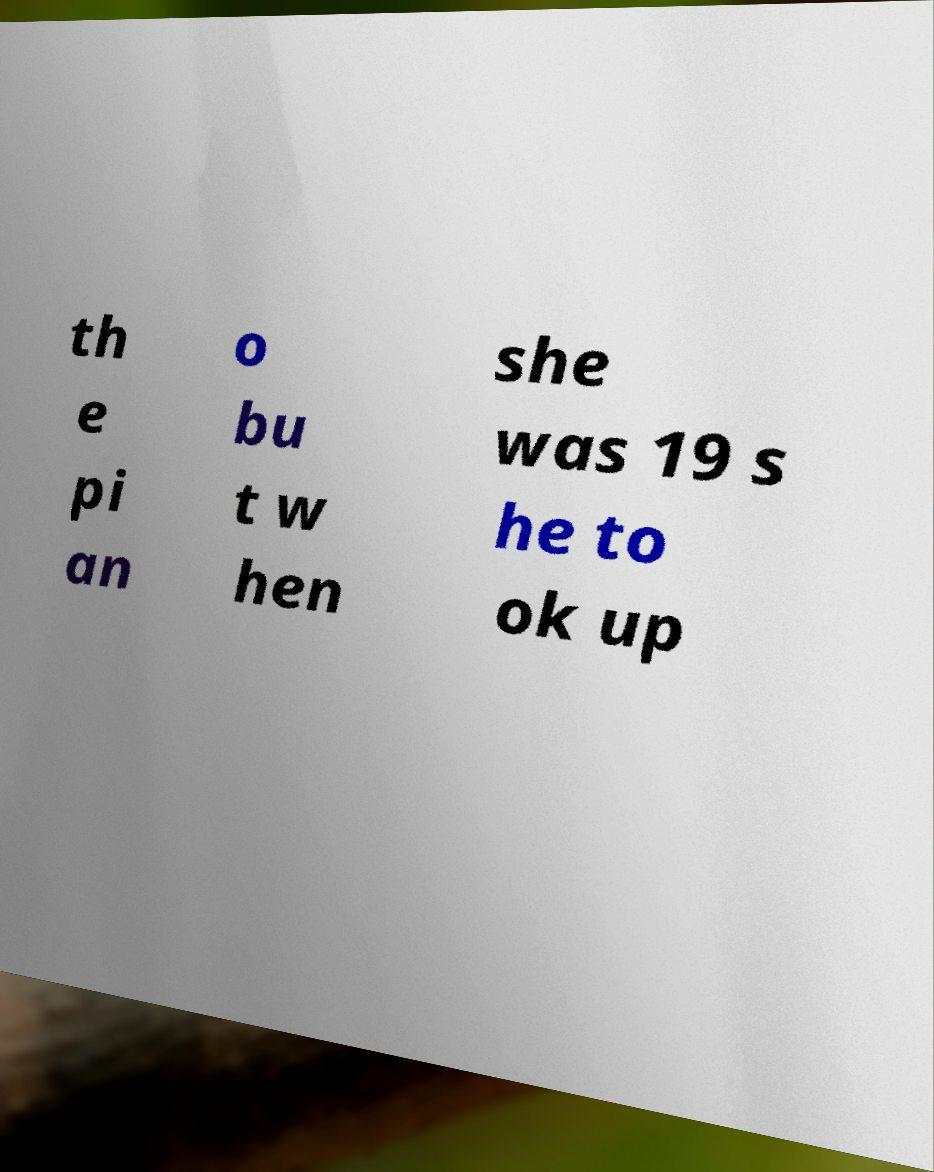Can you read and provide the text displayed in the image?This photo seems to have some interesting text. Can you extract and type it out for me? th e pi an o bu t w hen she was 19 s he to ok up 